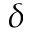<formula> <loc_0><loc_0><loc_500><loc_500>\delta</formula> 